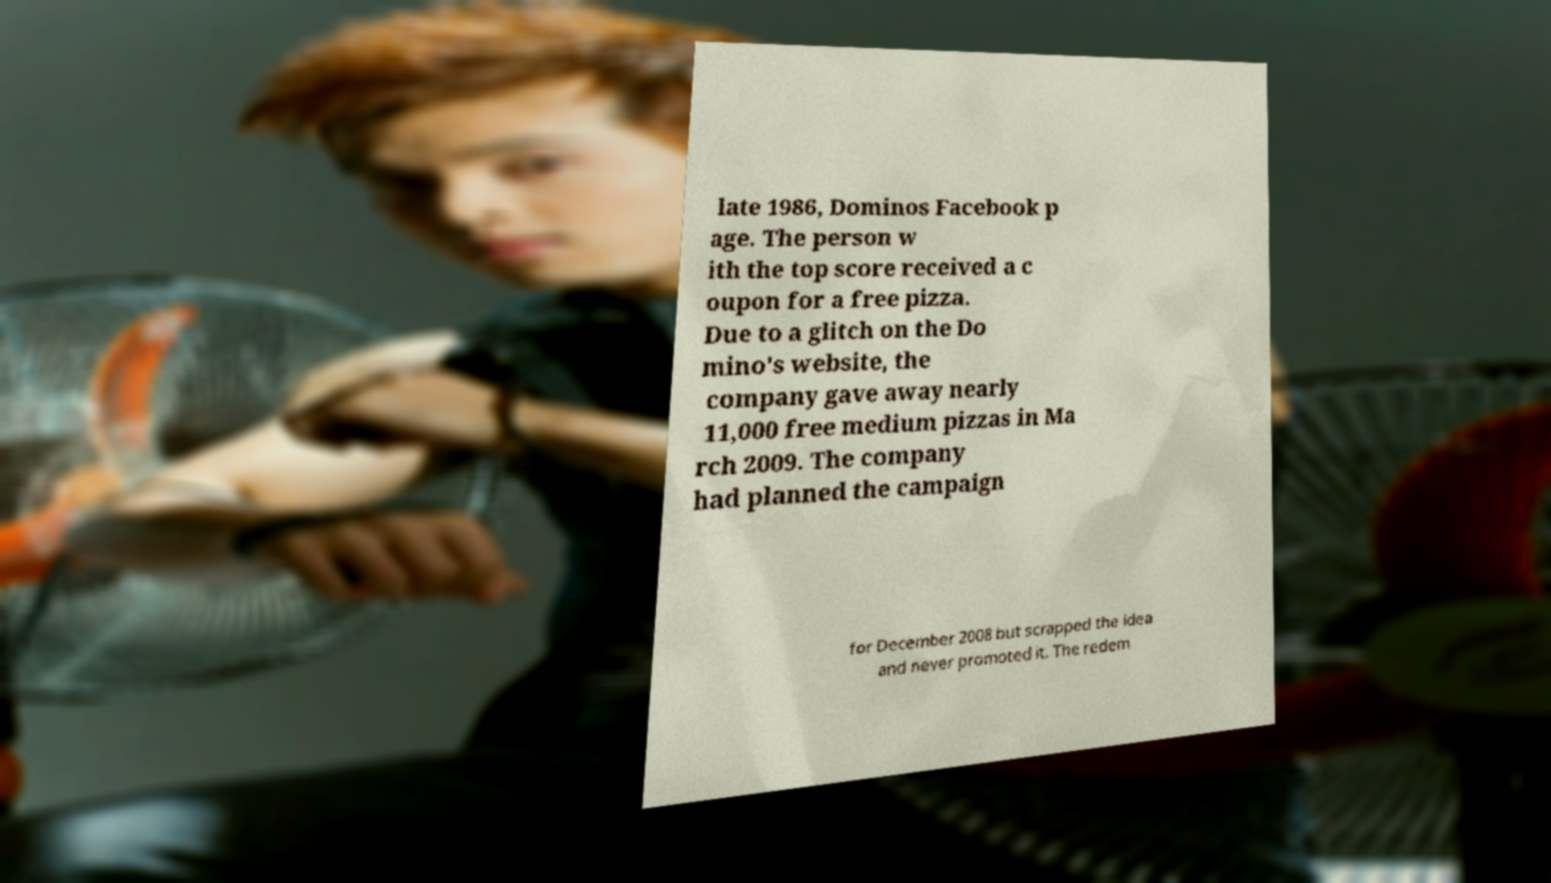Please identify and transcribe the text found in this image. late 1986, Dominos Facebook p age. The person w ith the top score received a c oupon for a free pizza. Due to a glitch on the Do mino's website, the company gave away nearly 11,000 free medium pizzas in Ma rch 2009. The company had planned the campaign for December 2008 but scrapped the idea and never promoted it. The redem 